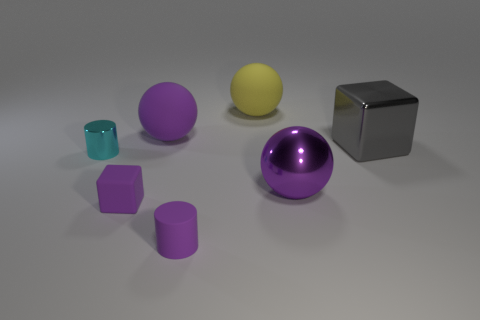How does the light source affect the appearance of the objects? The light source creates shadows and highlights on the objects, giving them depth and a three-dimensional feel. It appears to be above and slightly to the right, considering how the shadows fall to the left and below each object. Which object seems to reflect the most light? The metallic gray cube reflects the most light, as indicated by the bright specular highlights on its surface, which suggest it has a shinier material compared to the other objects. 